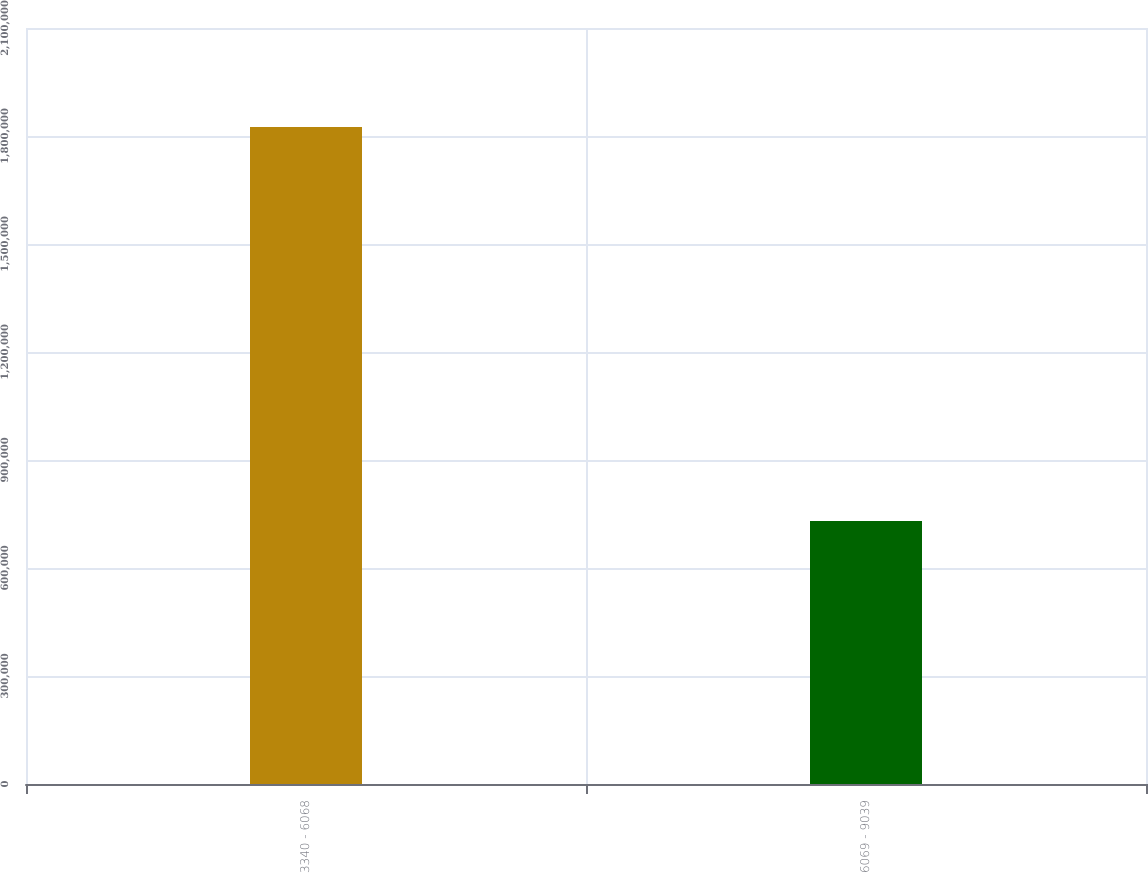<chart> <loc_0><loc_0><loc_500><loc_500><bar_chart><fcel>3340 - 6068<fcel>6069 - 9039<nl><fcel>1.82526e+06<fcel>730253<nl></chart> 